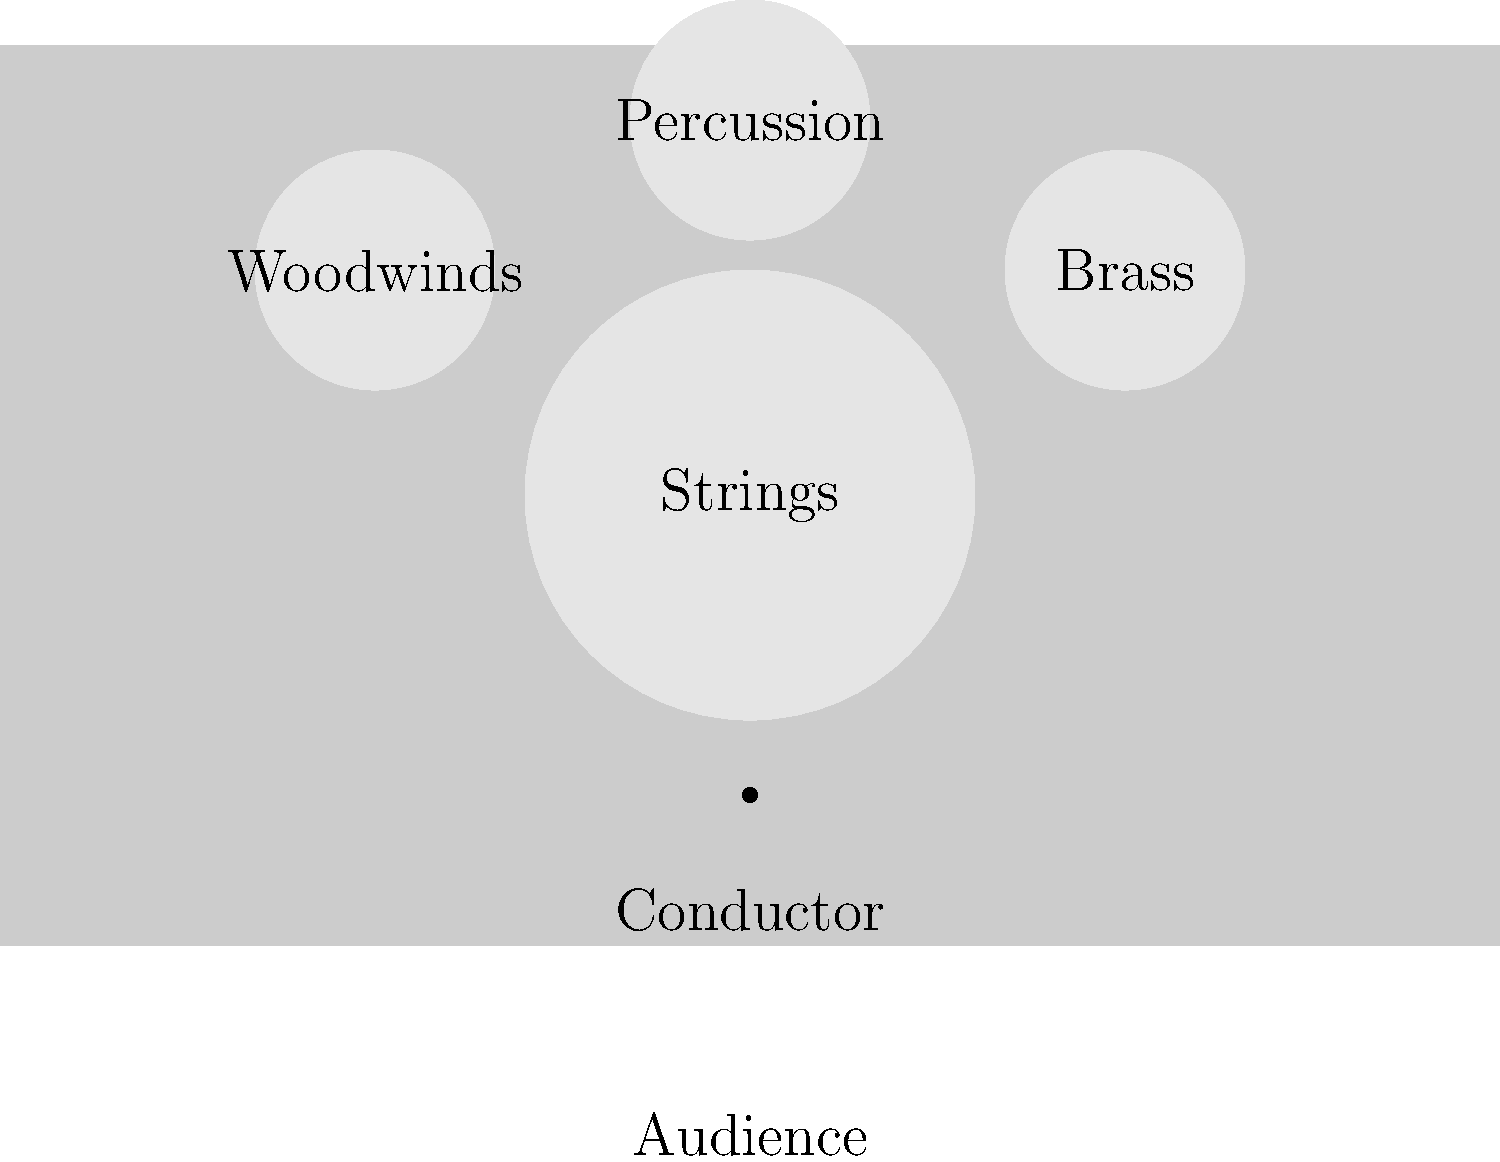Analyze the provided diagram of a modern symphony orchestra seating arrangement. How does this configuration differ from the typical seating arrangement during the Classical period (c. 1750-1820), and what factors contributed to these changes? To answer this question, we need to consider the evolution of orchestra seating arrangements from the Classical period to the modern era:

1. Classical period arrangement (c. 1750-1820):
   - Smaller orchestras, typically 30-40 players
   - Strings were divided on both sides of the conductor
   - Woodwinds were often placed in the center
   - Brass and percussion were less prominent and often at the back

2. Modern arrangement (as shown in the diagram):
   - Larger orchestras, often 80-100 players
   - Strings are grouped together in the front
   - Woodwinds, brass, and percussion have more defined sections

3. Factors contributing to these changes:
   a) Instrument development:
      - Improvements in brass and woodwind instruments led to increased prominence
      - New instruments were added to the orchestra (e.g., trombones, tubas)

   b) Compositional trends:
      - Romantic and post-Romantic composers wrote for larger, more diverse orchestras
      - Increased use of tone color and dynamic range required new arrangements

   c) Acoustic considerations:
      - Larger concert halls necessitated rethinking sound projection
      - Grouping similar instruments together improved blend and balance

   d) Conductor's role:
      - The rise of the conductor as an interpreter led to centralized leadership
      - Clear sight lines became more important for ensemble coordination

4. Key differences:
   - Size: Modern orchestras are significantly larger
   - Section grouping: Instruments are now grouped by family rather than divided
   - String placement: All strings are now typically placed at the front
   - Wind and percussion prominence: These sections now have more defined spaces and importance
Answer: Modern orchestras are larger, with instruments grouped by family (strings in front, winds and percussion behind), unlike the divided strings and central winds of the Classical period, due to instrument development, compositional trends, acoustic needs, and the evolving role of conductors. 